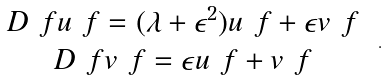<formula> <loc_0><loc_0><loc_500><loc_500>\begin{array} { c } D _ { \ } f u _ { \ } f = ( \lambda + \epsilon ^ { 2 } ) u _ { \ } f + \epsilon v _ { \ } f \\ D _ { \ } f v _ { \ } f = \epsilon u _ { \ } f + v _ { \ } f \end{array} \ .</formula> 